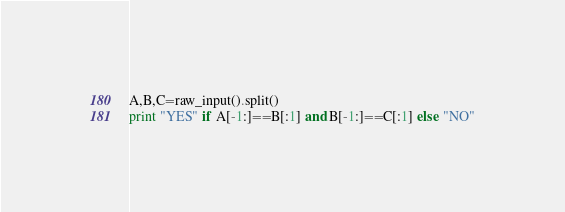<code> <loc_0><loc_0><loc_500><loc_500><_Python_>A,B,C=raw_input().split()
print "YES" if A[-1:]==B[:1] and B[-1:]==C[:1] else "NO"</code> 